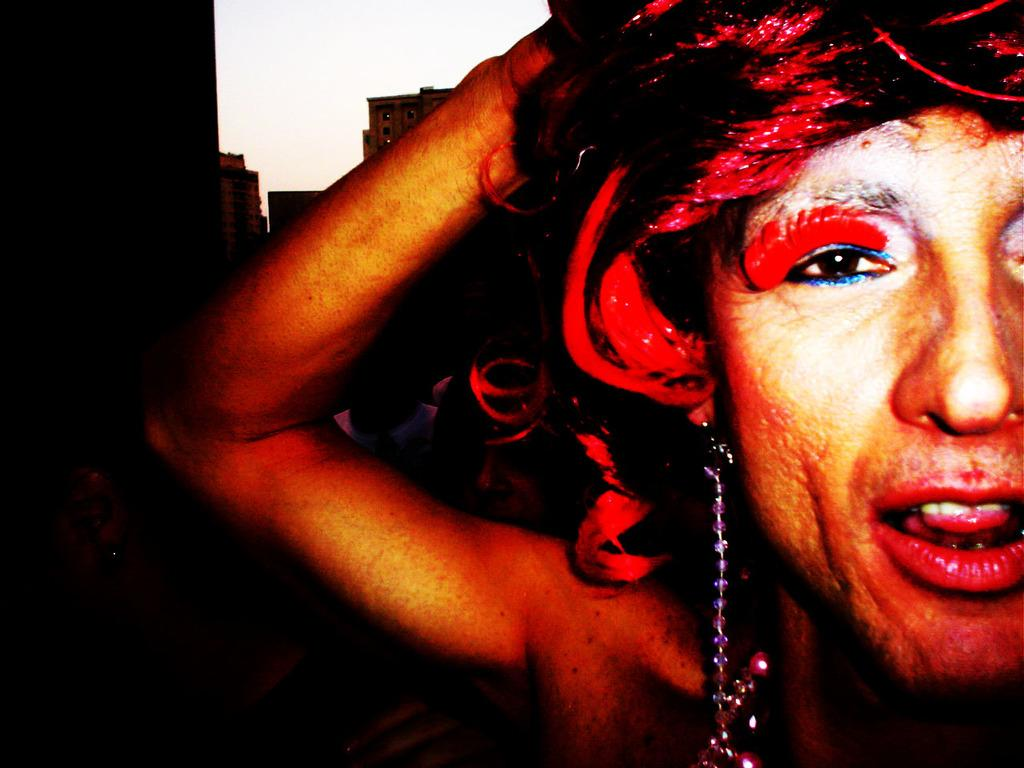What is the main subject of the image? There is a woman in the image. Can you describe the woman's appearance? The woman has red hair. What else can be seen in the image besides the woman? There are other objects in the background of the image. What type of button is the woman wearing on her shirt in the image? There is no button visible on the woman's shirt in the image. How does the woman walk in the image? The image is still, so we cannot see the woman walking. 